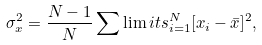Convert formula to latex. <formula><loc_0><loc_0><loc_500><loc_500>\sigma _ { x } ^ { 2 } = \frac { N - 1 } { N } \sum \lim i t s _ { i = 1 } ^ { N } [ x _ { i } - \bar { x } ] ^ { 2 } ,</formula> 